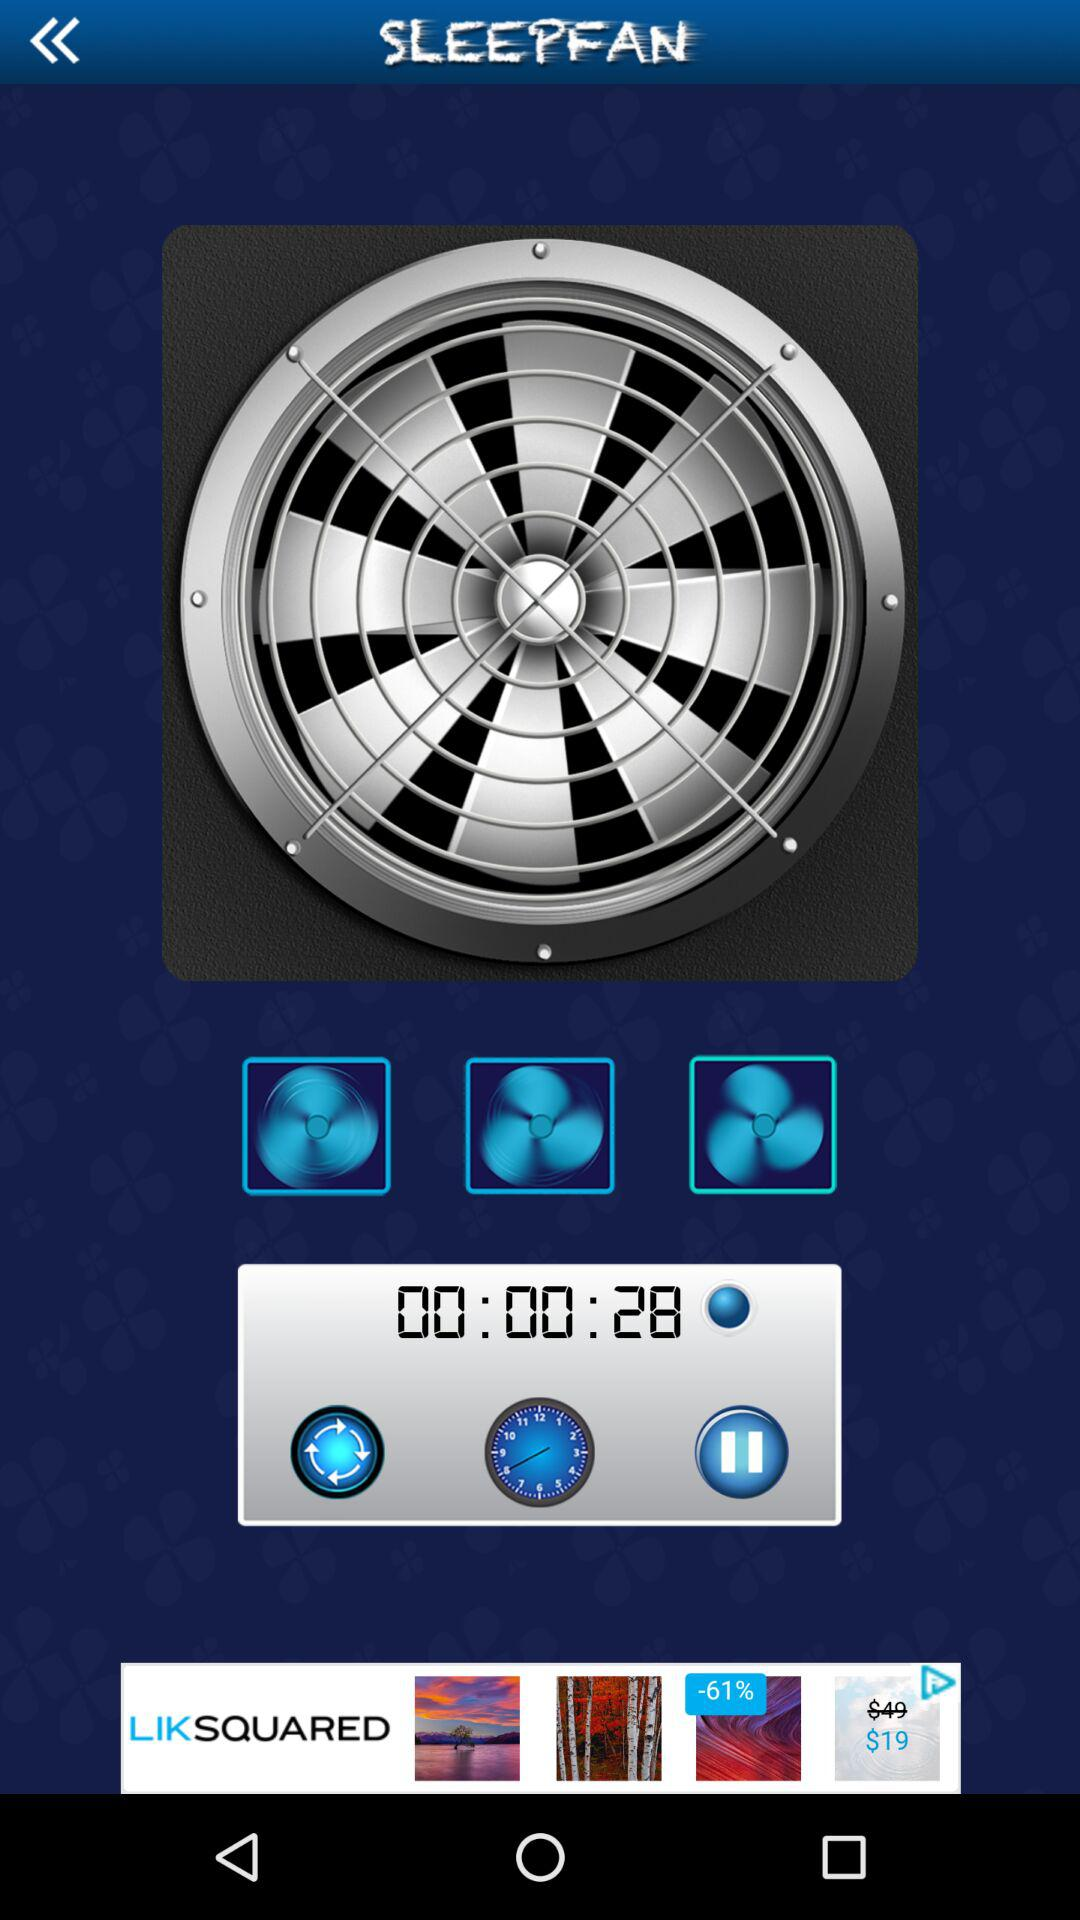What is the app name? The app name is "SLEEPFAN". 